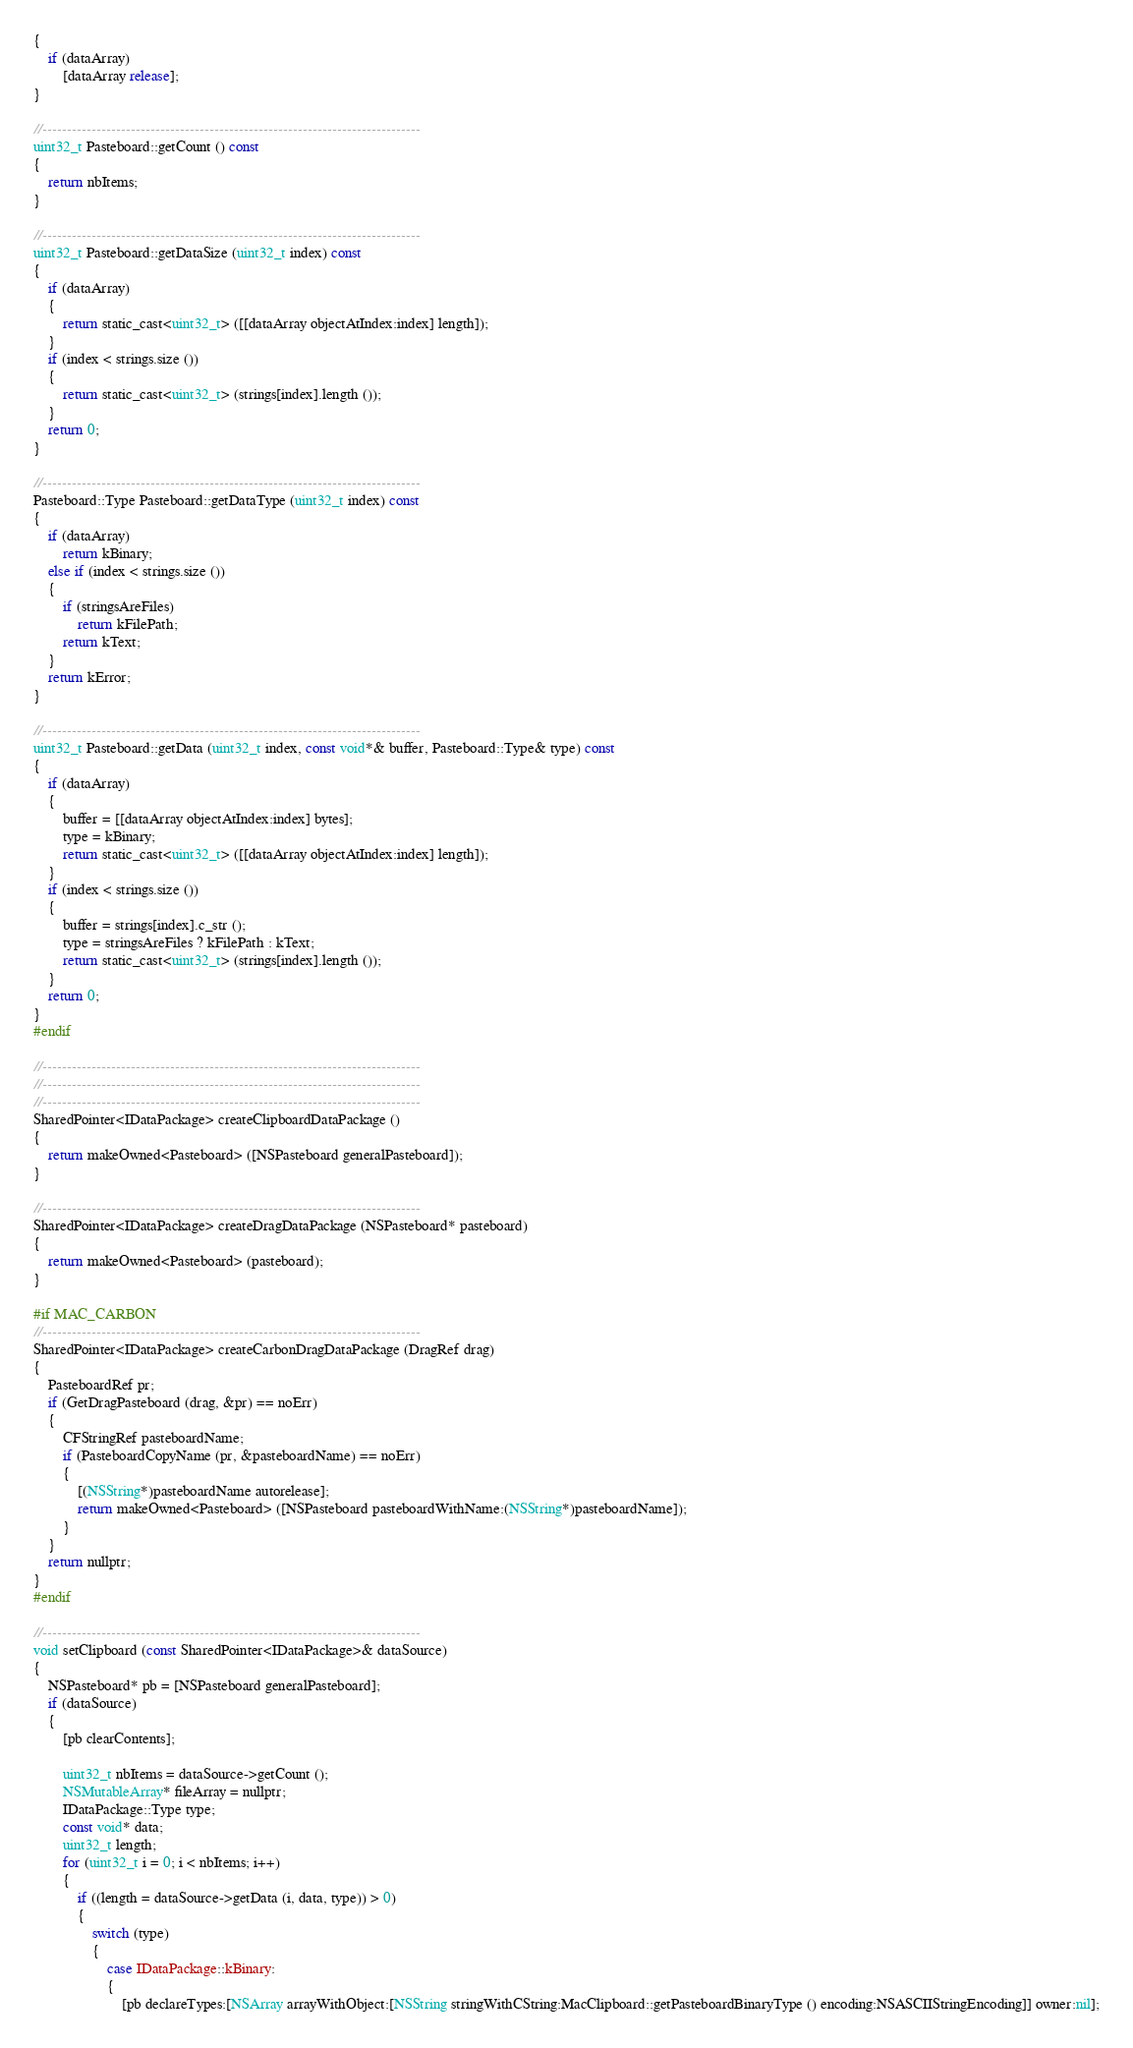<code> <loc_0><loc_0><loc_500><loc_500><_ObjectiveC_>{
	if (dataArray)
		[dataArray release];
}

//-----------------------------------------------------------------------------
uint32_t Pasteboard::getCount () const
{
	return nbItems;
}

//-----------------------------------------------------------------------------
uint32_t Pasteboard::getDataSize (uint32_t index) const
{
	if (dataArray)
	{
		return static_cast<uint32_t> ([[dataArray objectAtIndex:index] length]);
	}
	if (index < strings.size ())
	{
		return static_cast<uint32_t> (strings[index].length ());
	}
	return 0;
}

//-----------------------------------------------------------------------------
Pasteboard::Type Pasteboard::getDataType (uint32_t index) const
{
	if (dataArray)
		return kBinary;
	else if (index < strings.size ())
	{
		if (stringsAreFiles)
			return kFilePath;
		return kText;
	}
	return kError;
}

//-----------------------------------------------------------------------------
uint32_t Pasteboard::getData (uint32_t index, const void*& buffer, Pasteboard::Type& type) const
{
	if (dataArray)
	{
		buffer = [[dataArray objectAtIndex:index] bytes];
		type = kBinary;
		return static_cast<uint32_t> ([[dataArray objectAtIndex:index] length]);
	}
	if (index < strings.size ())
	{
		buffer = strings[index].c_str ();
		type = stringsAreFiles ? kFilePath : kText;
		return static_cast<uint32_t> (strings[index].length ());
	}
	return 0;
}
#endif

//-----------------------------------------------------------------------------
//-----------------------------------------------------------------------------
//-----------------------------------------------------------------------------
SharedPointer<IDataPackage> createClipboardDataPackage ()
{
	return makeOwned<Pasteboard> ([NSPasteboard generalPasteboard]);
}

//-----------------------------------------------------------------------------
SharedPointer<IDataPackage> createDragDataPackage (NSPasteboard* pasteboard)
{
	return makeOwned<Pasteboard> (pasteboard);
}

#if MAC_CARBON
//-----------------------------------------------------------------------------
SharedPointer<IDataPackage> createCarbonDragDataPackage (DragRef drag)
{
	PasteboardRef pr;
	if (GetDragPasteboard (drag, &pr) == noErr)
	{
		CFStringRef pasteboardName;
		if (PasteboardCopyName (pr, &pasteboardName) == noErr)
		{
			[(NSString*)pasteboardName autorelease];
			return makeOwned<Pasteboard> ([NSPasteboard pasteboardWithName:(NSString*)pasteboardName]);
		}
	}
	return nullptr;
}
#endif

//-----------------------------------------------------------------------------
void setClipboard (const SharedPointer<IDataPackage>& dataSource)
{
	NSPasteboard* pb = [NSPasteboard generalPasteboard];
	if (dataSource)
	{
		[pb clearContents];

		uint32_t nbItems = dataSource->getCount ();
		NSMutableArray* fileArray = nullptr;
		IDataPackage::Type type;
		const void* data;
		uint32_t length;
		for (uint32_t i = 0; i < nbItems; i++)
		{
			if ((length = dataSource->getData (i, data, type)) > 0)
			{
				switch (type)
				{
					case IDataPackage::kBinary:
					{
						[pb declareTypes:[NSArray arrayWithObject:[NSString stringWithCString:MacClipboard::getPasteboardBinaryType () encoding:NSASCIIStringEncoding]] owner:nil];</code> 